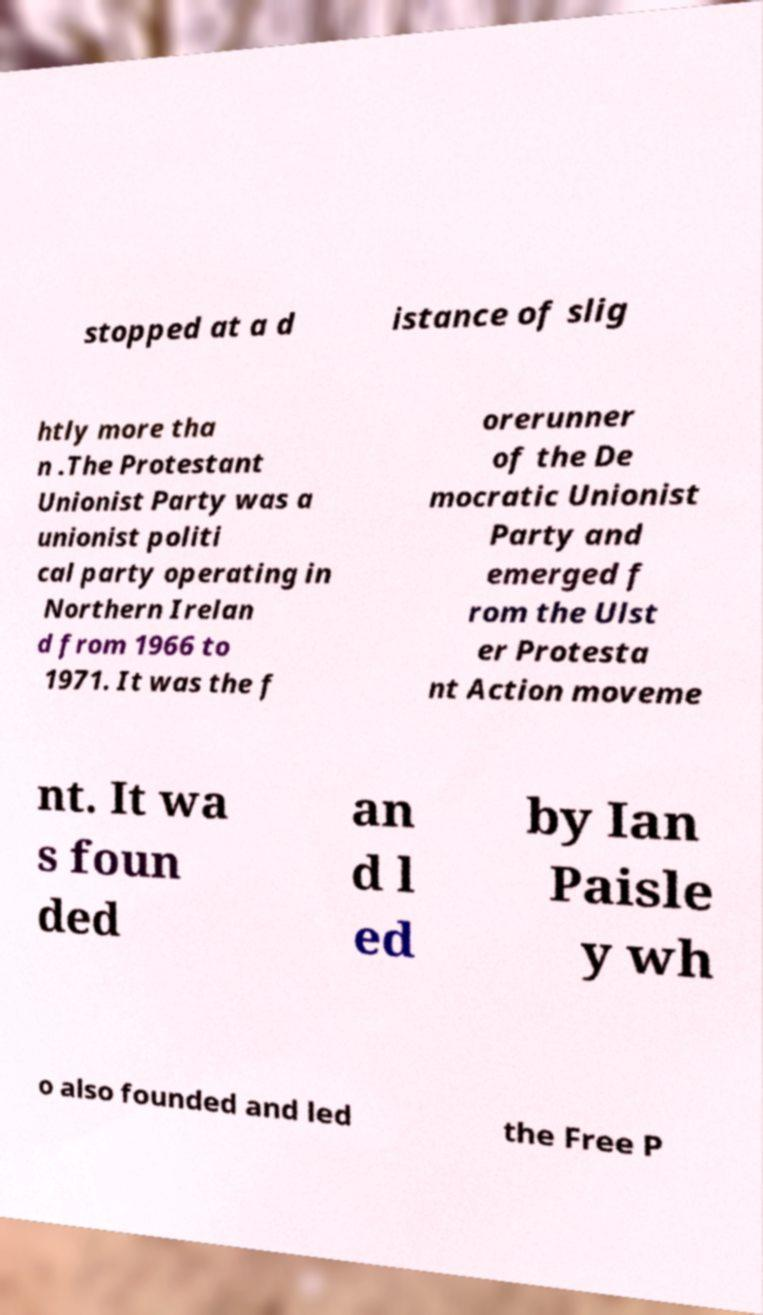Please identify and transcribe the text found in this image. stopped at a d istance of slig htly more tha n .The Protestant Unionist Party was a unionist politi cal party operating in Northern Irelan d from 1966 to 1971. It was the f orerunner of the De mocratic Unionist Party and emerged f rom the Ulst er Protesta nt Action moveme nt. It wa s foun ded an d l ed by Ian Paisle y wh o also founded and led the Free P 